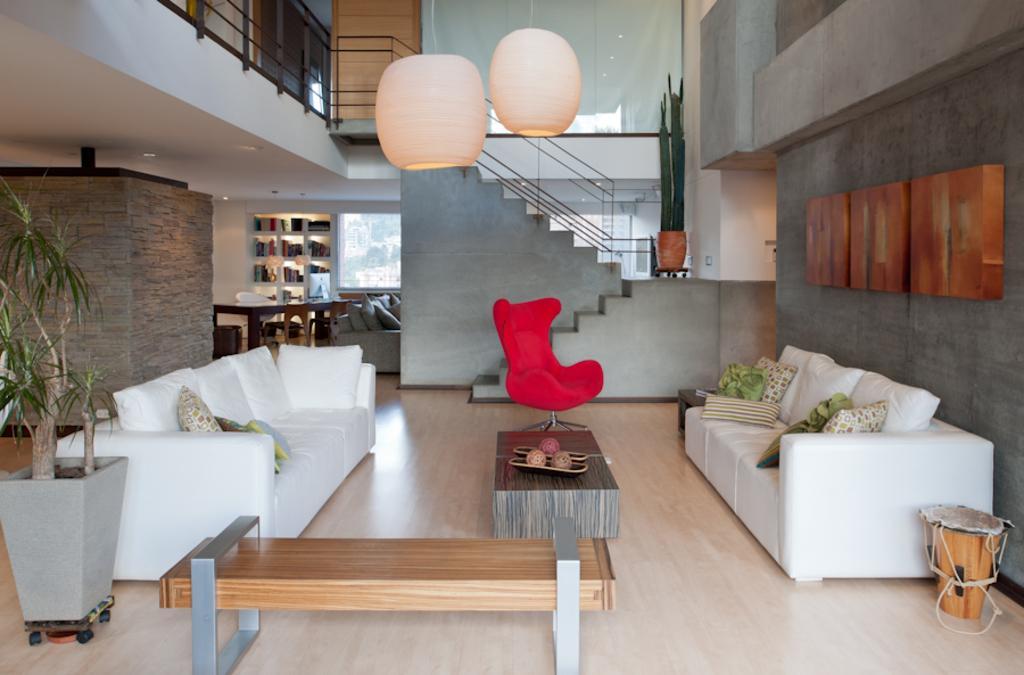Describe this image in one or two sentences. There are two white sofas on the either side and there is a table and a red chair in between them and there is also a stair case and book shelf in background. 